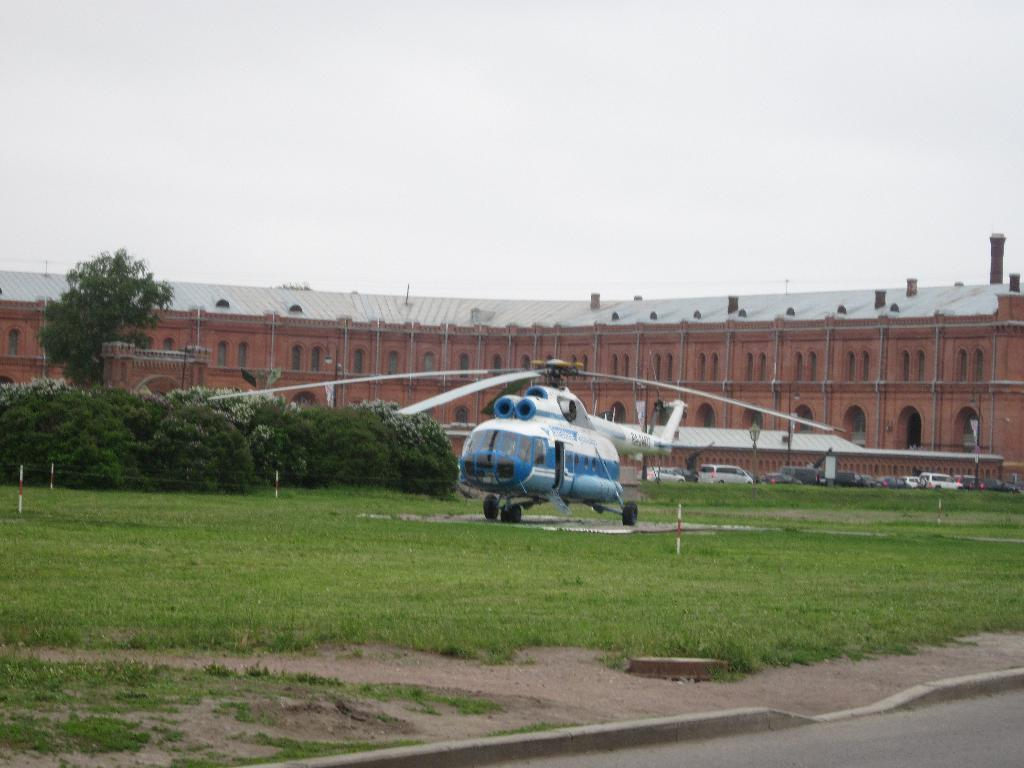What type of structures can be seen in the image? There are buildings in the image. What natural elements are present in the image? There are trees and bushes in the image. What can be seen on the ground in the image? The ground is visible in the surface visible in the image. What type of transportation infrastructure is present in the image? There is a road in the image. What vehicles can be seen in the image? There are cars in the image. What type of aircraft is present in the image? There is a helicopter in the image. What type of paper can be seen in the image? There is no paper present in the image. What shape is the kitty sitting in the image? There is no kitty present in the image. 